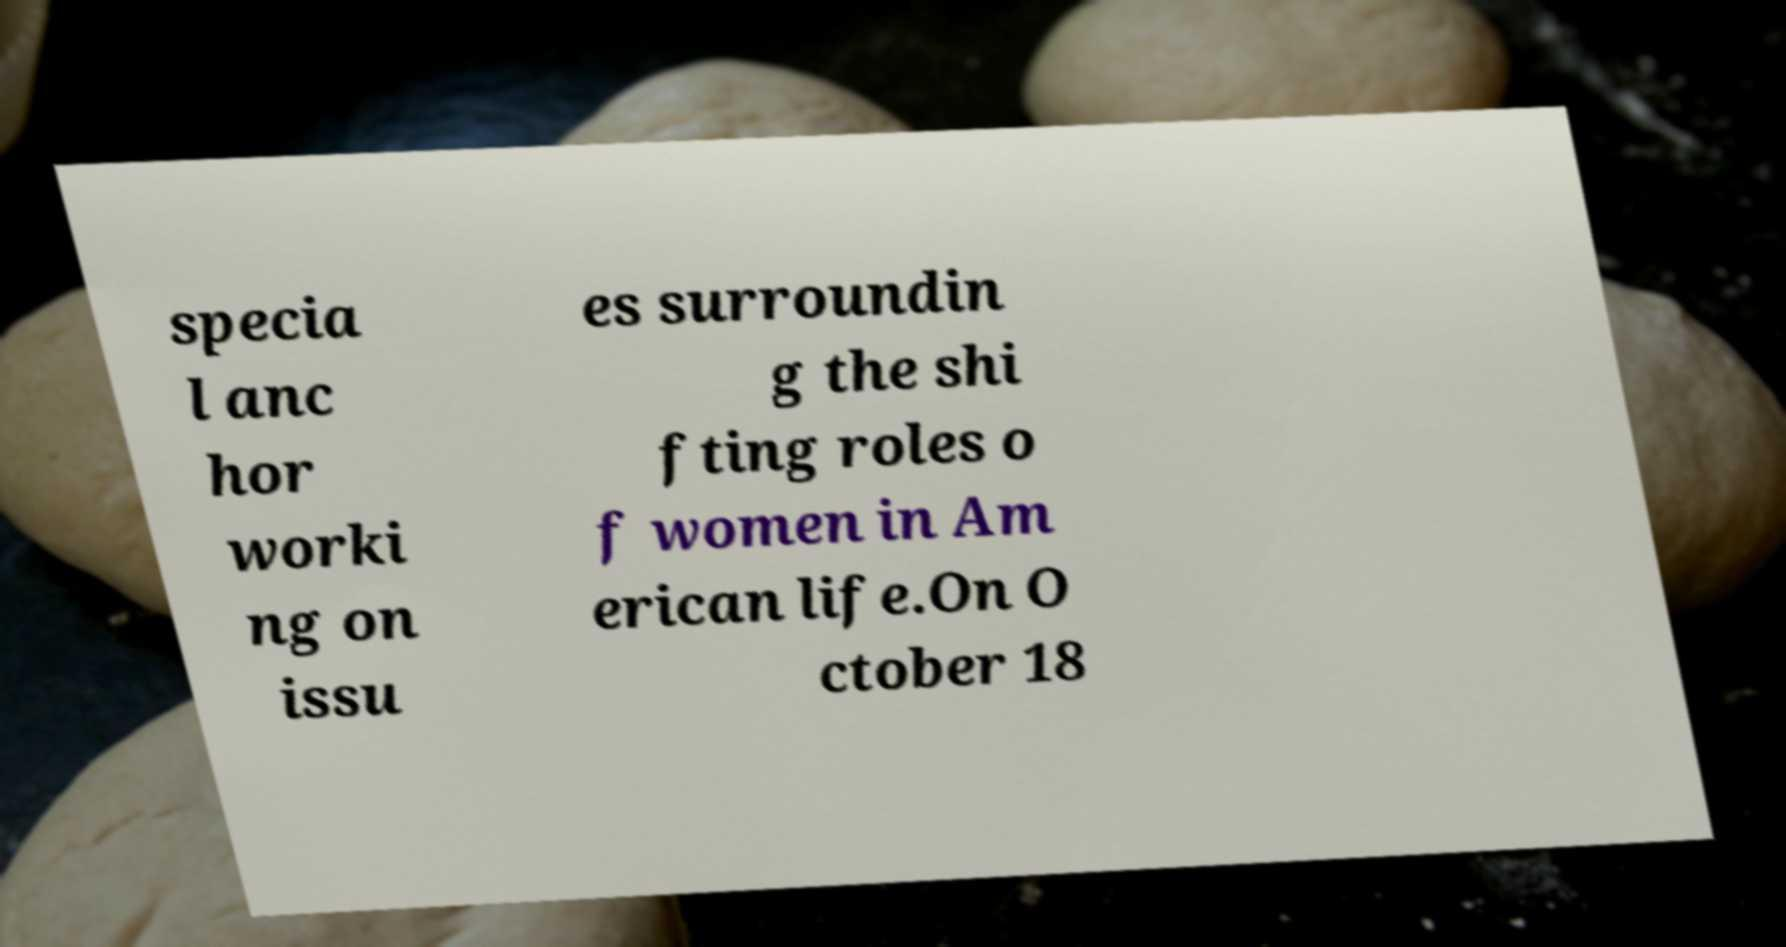Please read and relay the text visible in this image. What does it say? specia l anc hor worki ng on issu es surroundin g the shi fting roles o f women in Am erican life.On O ctober 18 